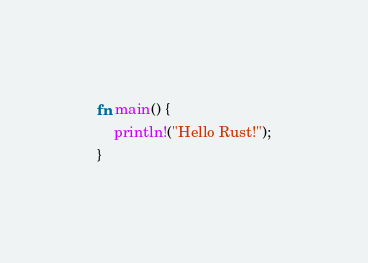<code> <loc_0><loc_0><loc_500><loc_500><_Rust_>
fn main() {
    println!("Hello Rust!");
}</code> 